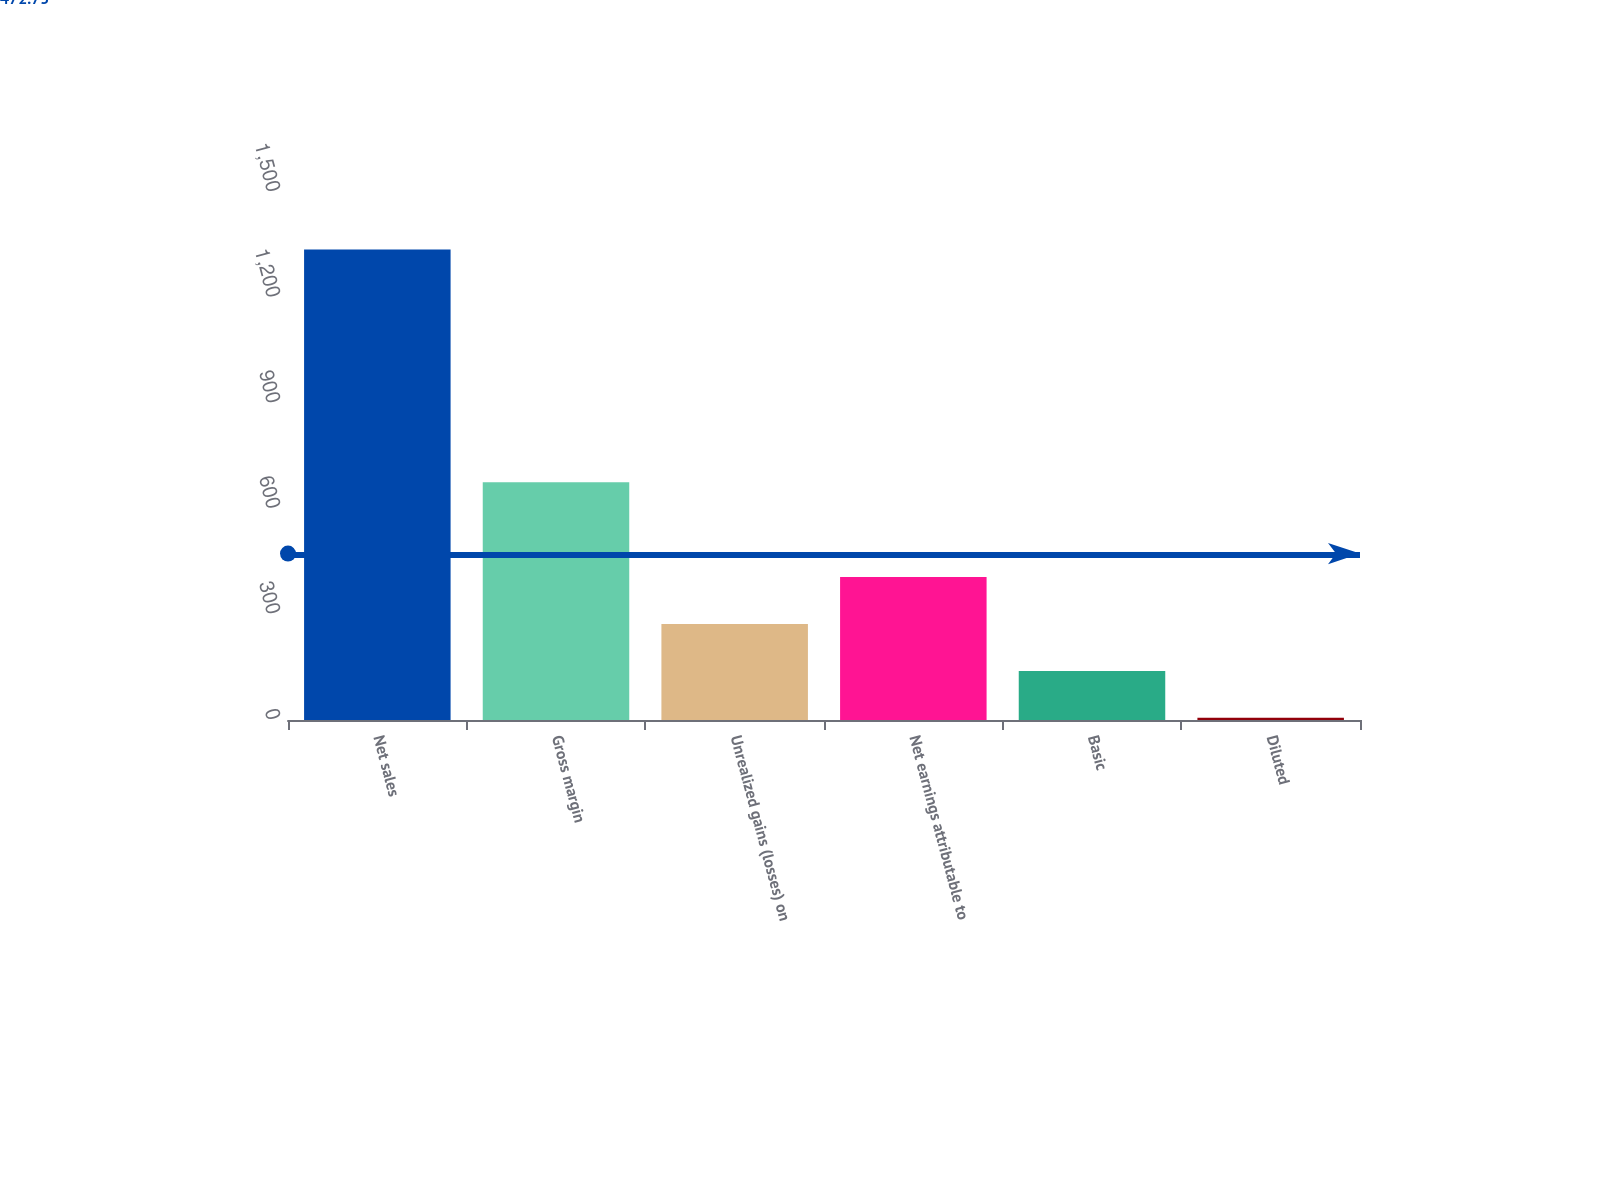Convert chart to OTSL. <chart><loc_0><loc_0><loc_500><loc_500><bar_chart><fcel>Net sales<fcel>Gross margin<fcel>Unrealized gains (losses) on<fcel>Net earnings attributable to<fcel>Basic<fcel>Diluted<nl><fcel>1336.5<fcel>675.1<fcel>272.47<fcel>406.5<fcel>139.47<fcel>6.47<nl></chart> 